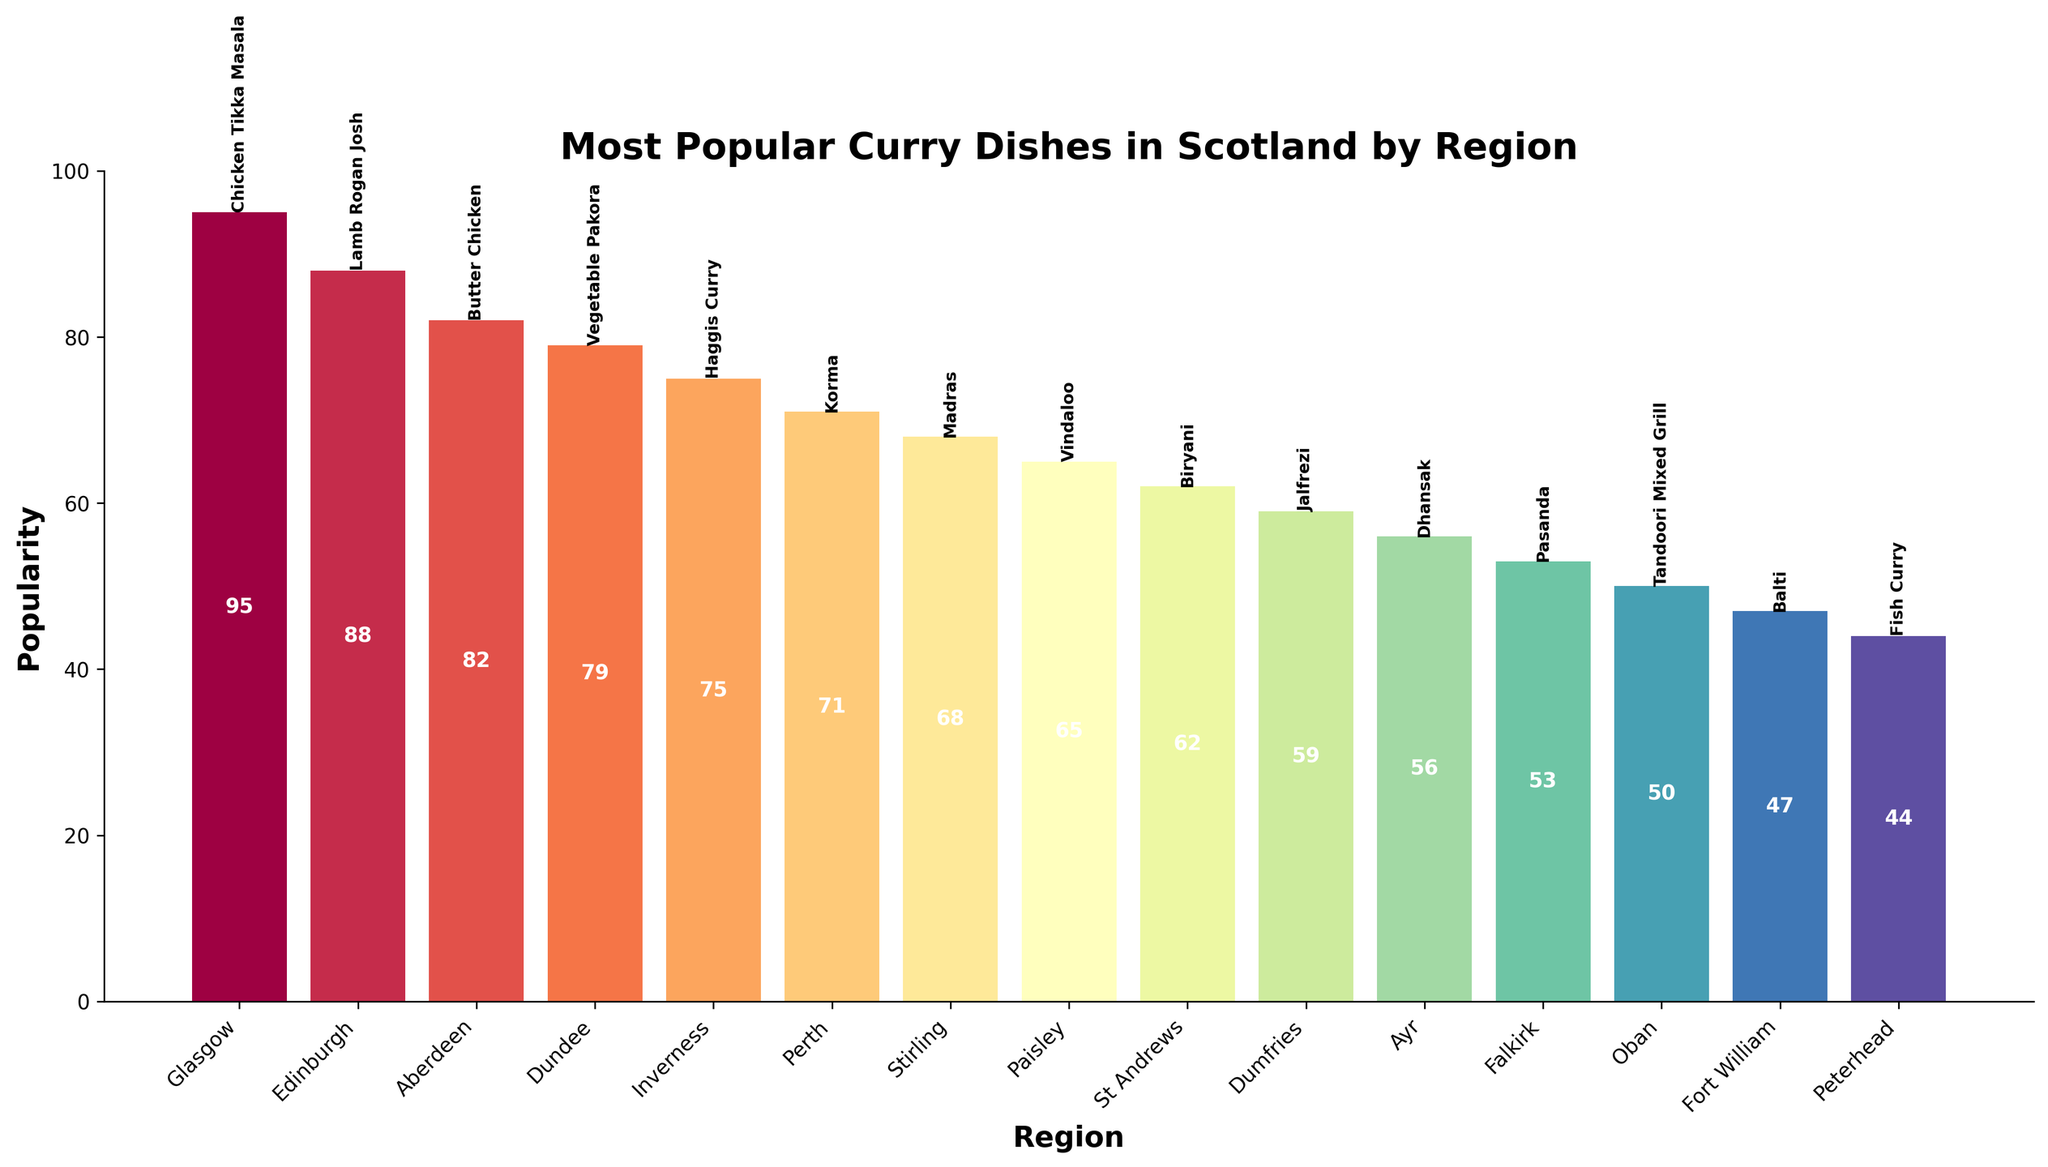Which region's most popular curry dish has the highest popularity? To find the region with the highest popularity, look for the tallest bar in the chart. The tallest bar corresponds to Glasgow, with a popularity of 95 for Chicken Tikka Masala.
Answer: Glasgow Which region's most popular curry dish has the lowest popularity? Locate the shortest bar in the chart. The shortest bar corresponds to Peterhead, with a popularity of 44 for Fish Curry.
Answer: Peterhead How much more popular is Chicken Tikka Masala in Glasgow compared to Pasanda in Falkirk? Find the popularity values for both dishes and subtract the smaller number from the larger one. Chicken Tikka Masala in Glasgow has a popularity of 95, and Pasanda in Falkirk has a popularity of 53. The difference is 95 - 53 = 42.
Answer: 42 What is the combined popularity of the curry dishes in Edinburgh and Dundee? Find the popularity for the dishes in Edinburgh and Dundee and add them together. Edinburgh's Lamb Rogan Josh has a popularity of 88, and Dundee's Vegetable Pakora has a popularity of 79. The combined value is 88 + 79 = 167.
Answer: 167 Which curry dish is associated with Inverness, and what is its popularity? Locate the information related to Inverness. The chart shows that Inverness's most popular dish is Haggis Curry, with a popularity of 75.
Answer: Haggis Curry, 75 Which region has a more popular curry dish: St Andrews or Dumfries? Compare the popularity values for both regions. St Andrews has Biryani with a popularity of 62, and Dumfries has Jalfrezi with a popularity of 59. 62 is greater than 59, so St Andrews has a more popular dish.
Answer: St Andrews Identify the curry dish that has a popularity of 68 and the corresponding region. Find the bar labeled with the value 68. The chart shows that Madras in Stirling has a popularity of 68.
Answer: Madras, Stirling Calculate the average popularity of the curry dishes in Fort William, Oban, and Peterhead. Sum the popularity values for these regions and divide by the number of regions (3). Fort William's Balti is 47, Oban's Tandoori Mixed Grill is 50, and Peterhead's Fish Curry is 44. The sum is 47 + 50 + 44 = 141. Dividing by 3, the average is 141 / 3 = 47.
Answer: 47 Which region has a dish called Butter Chicken and what is its popularity relative to Fish Curry in Peterhead? Locate the region and popularity of Butter Chicken. Aberdeen has Butter Chicken with a popularity of 82. Compare this to Fish Curry in Peterhead, which has a popularity of 44. Butter Chicken's popularity is higher.
Answer: Aberdeen, higher 